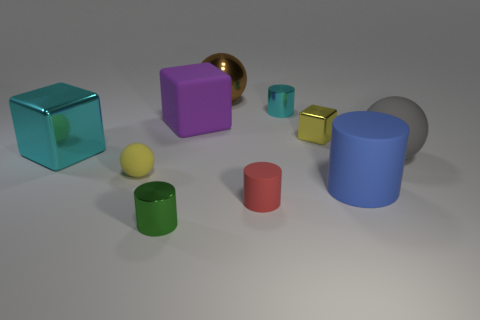There is a small shiny cylinder that is behind the big rubber ball that is behind the blue object; is there a small red rubber thing that is behind it?
Give a very brief answer. No. What number of large brown cylinders are there?
Your answer should be very brief. 0. How many things are tiny shiny cylinders that are behind the big blue cylinder or large things that are behind the tiny cyan thing?
Keep it short and to the point. 2. There is a metallic block that is to the right of the cyan cylinder; is its size the same as the gray matte thing?
Keep it short and to the point. No. There is a shiny object that is the same shape as the large gray rubber object; what size is it?
Your answer should be compact. Large. There is a brown ball that is the same size as the gray sphere; what material is it?
Your response must be concise. Metal. What material is the green object that is the same shape as the small cyan metallic object?
Give a very brief answer. Metal. How many other objects are the same size as the gray ball?
Give a very brief answer. 4. There is a rubber object that is the same color as the small metallic cube; what size is it?
Provide a succinct answer. Small. How many small rubber cylinders are the same color as the tiny rubber sphere?
Provide a short and direct response. 0. 